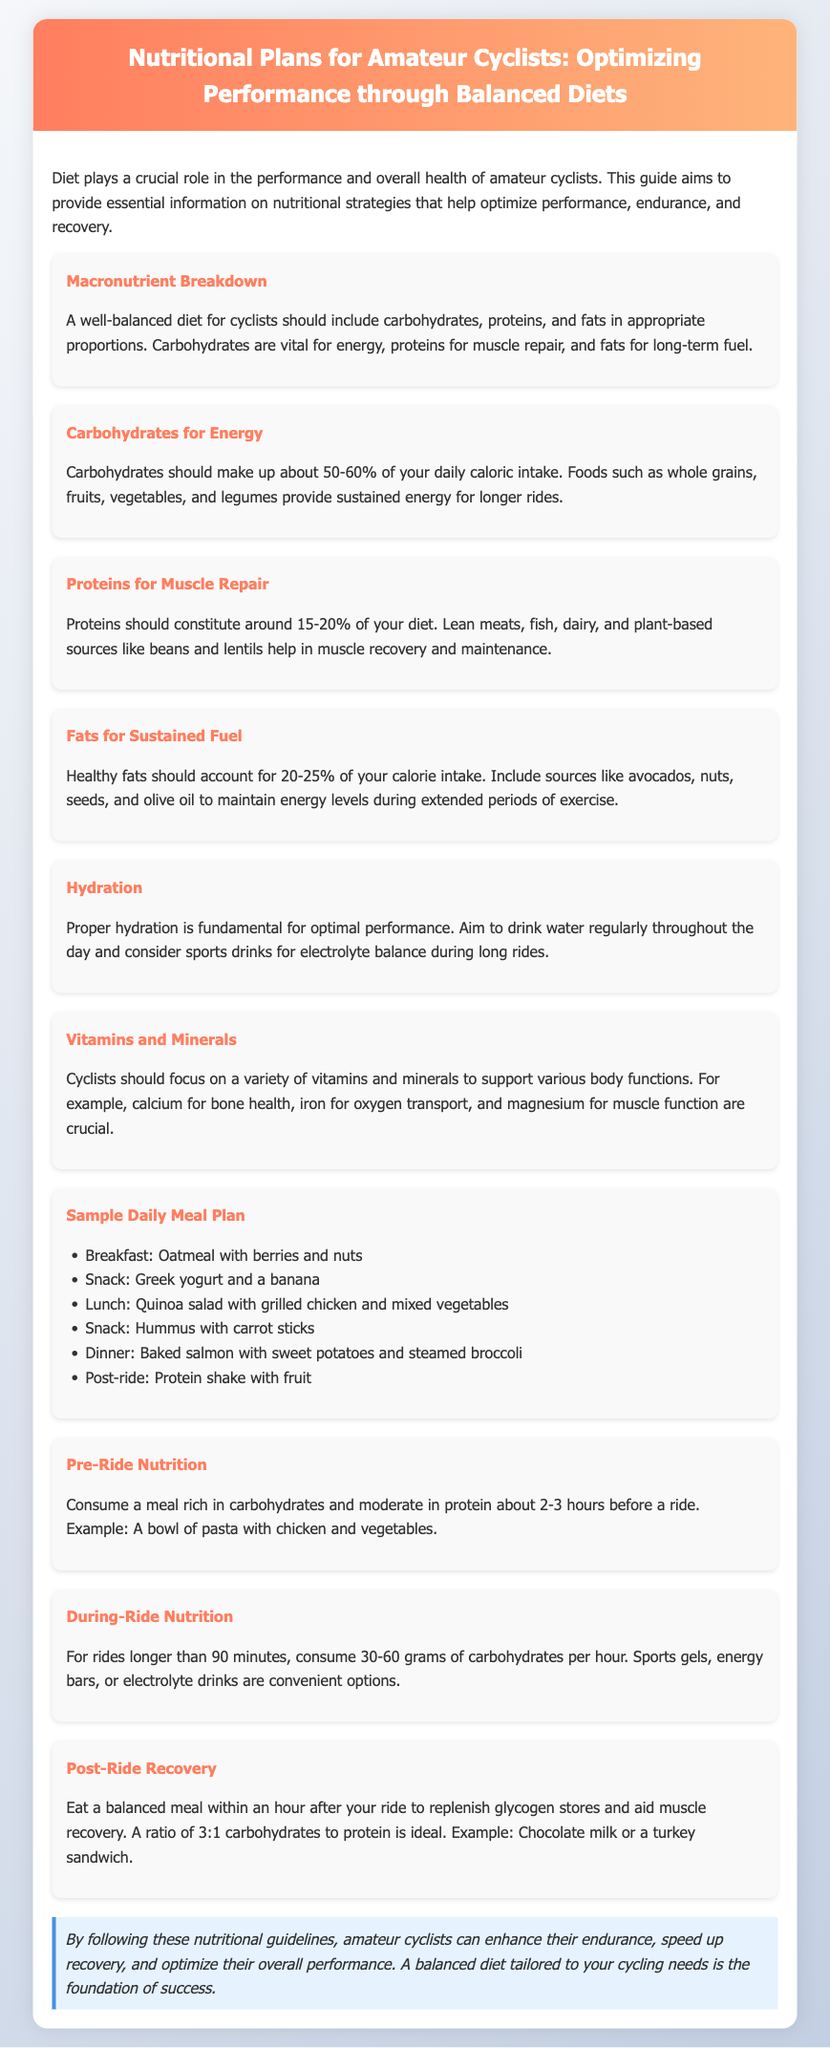What is the primary focus of the document? The document focuses on the nutritional strategies to optimize performance for amateur cyclists.
Answer: Nutritional strategies What percentage of daily caloric intake should carbohydrates constitute? The document states that carbohydrates should make up about 50-60% of daily caloric intake.
Answer: 50-60% What foods are suggested for post-ride recovery? The document mentions chocolate milk or a turkey sandwich as examples for post-ride recovery.
Answer: Chocolate milk or a turkey sandwich How much carbohydrates should a cyclist consume per hour during rides longer than 90 minutes? According to the document, cyclists should consume 30-60 grams of carbohydrates per hour during such rides.
Answer: 30-60 grams What type of meal is recommended before a ride? The document recommends a meal rich in carbohydrates and moderate in protein about 2-3 hours before a ride.
Answer: Carbohydrates and moderate protein What is the ideal ratio of carbohydrates to protein for post-ride recovery? The ideal ratio of carbohydrates to protein for post-ride recovery is stated as 3:1.
Answer: 3:1 Which nutrient is crucial for muscle repair? The document highlights proteins as crucial for muscle repair.
Answer: Proteins What is the role of healthy fats in a cyclist's diet? Healthy fats are included to maintain energy levels during extended periods of exercise.
Answer: Maintain energy levels 